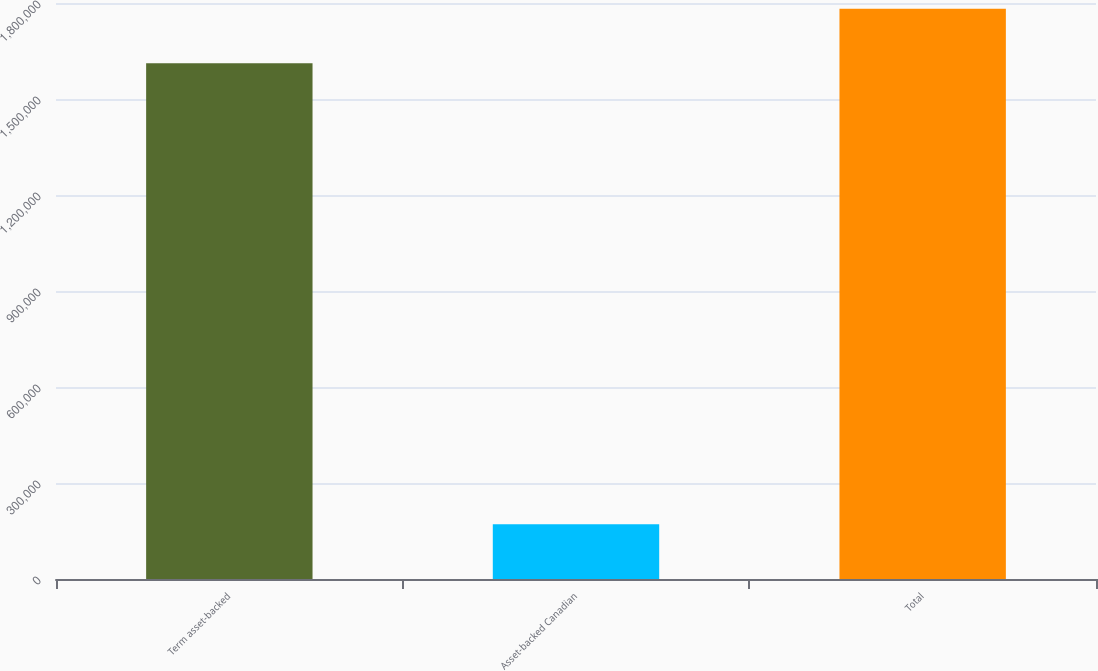<chart> <loc_0><loc_0><loc_500><loc_500><bar_chart><fcel>Term asset-backed<fcel>Asset-backed Canadian<fcel>Total<nl><fcel>1.61162e+06<fcel>170708<fcel>1.78233e+06<nl></chart> 